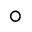Convert formula to latex. <formula><loc_0><loc_0><loc_500><loc_500>^ { \circ }</formula> 